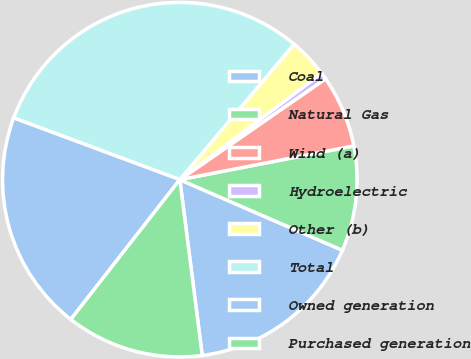Convert chart to OTSL. <chart><loc_0><loc_0><loc_500><loc_500><pie_chart><fcel>Coal<fcel>Natural Gas<fcel>Wind (a)<fcel>Hydroelectric<fcel>Other (b)<fcel>Total<fcel>Owned generation<fcel>Purchased generation<nl><fcel>16.46%<fcel>9.57%<fcel>6.59%<fcel>0.61%<fcel>3.6%<fcel>30.49%<fcel>20.12%<fcel>12.56%<nl></chart> 